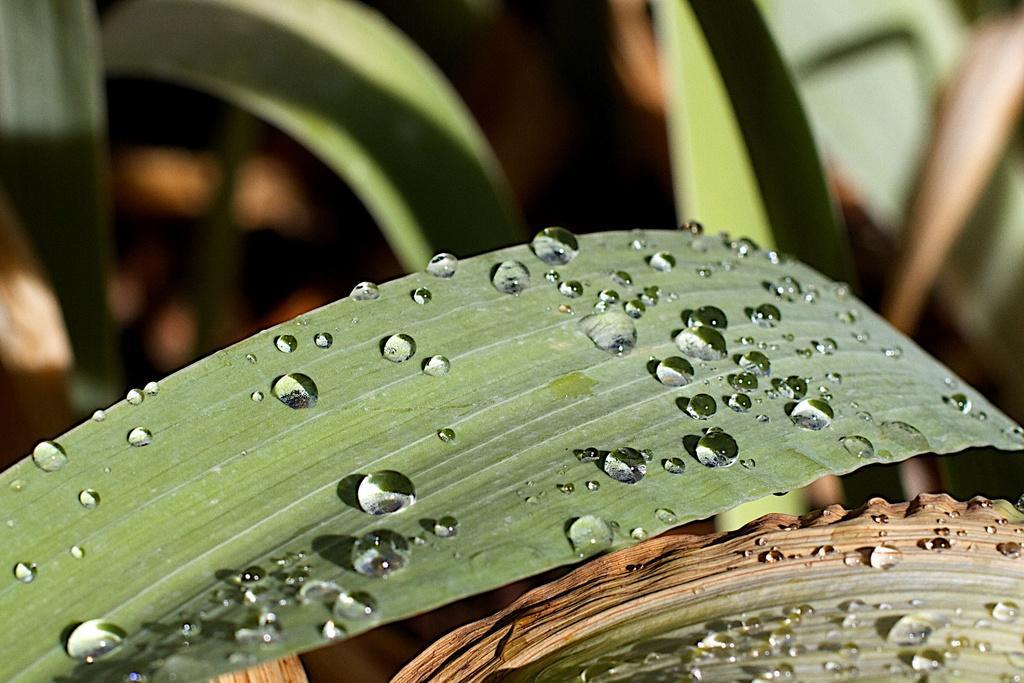How would you summarize this image in a sentence or two? This image consists of a plant. In the front, we can see a leaf on which there are water droplets. 